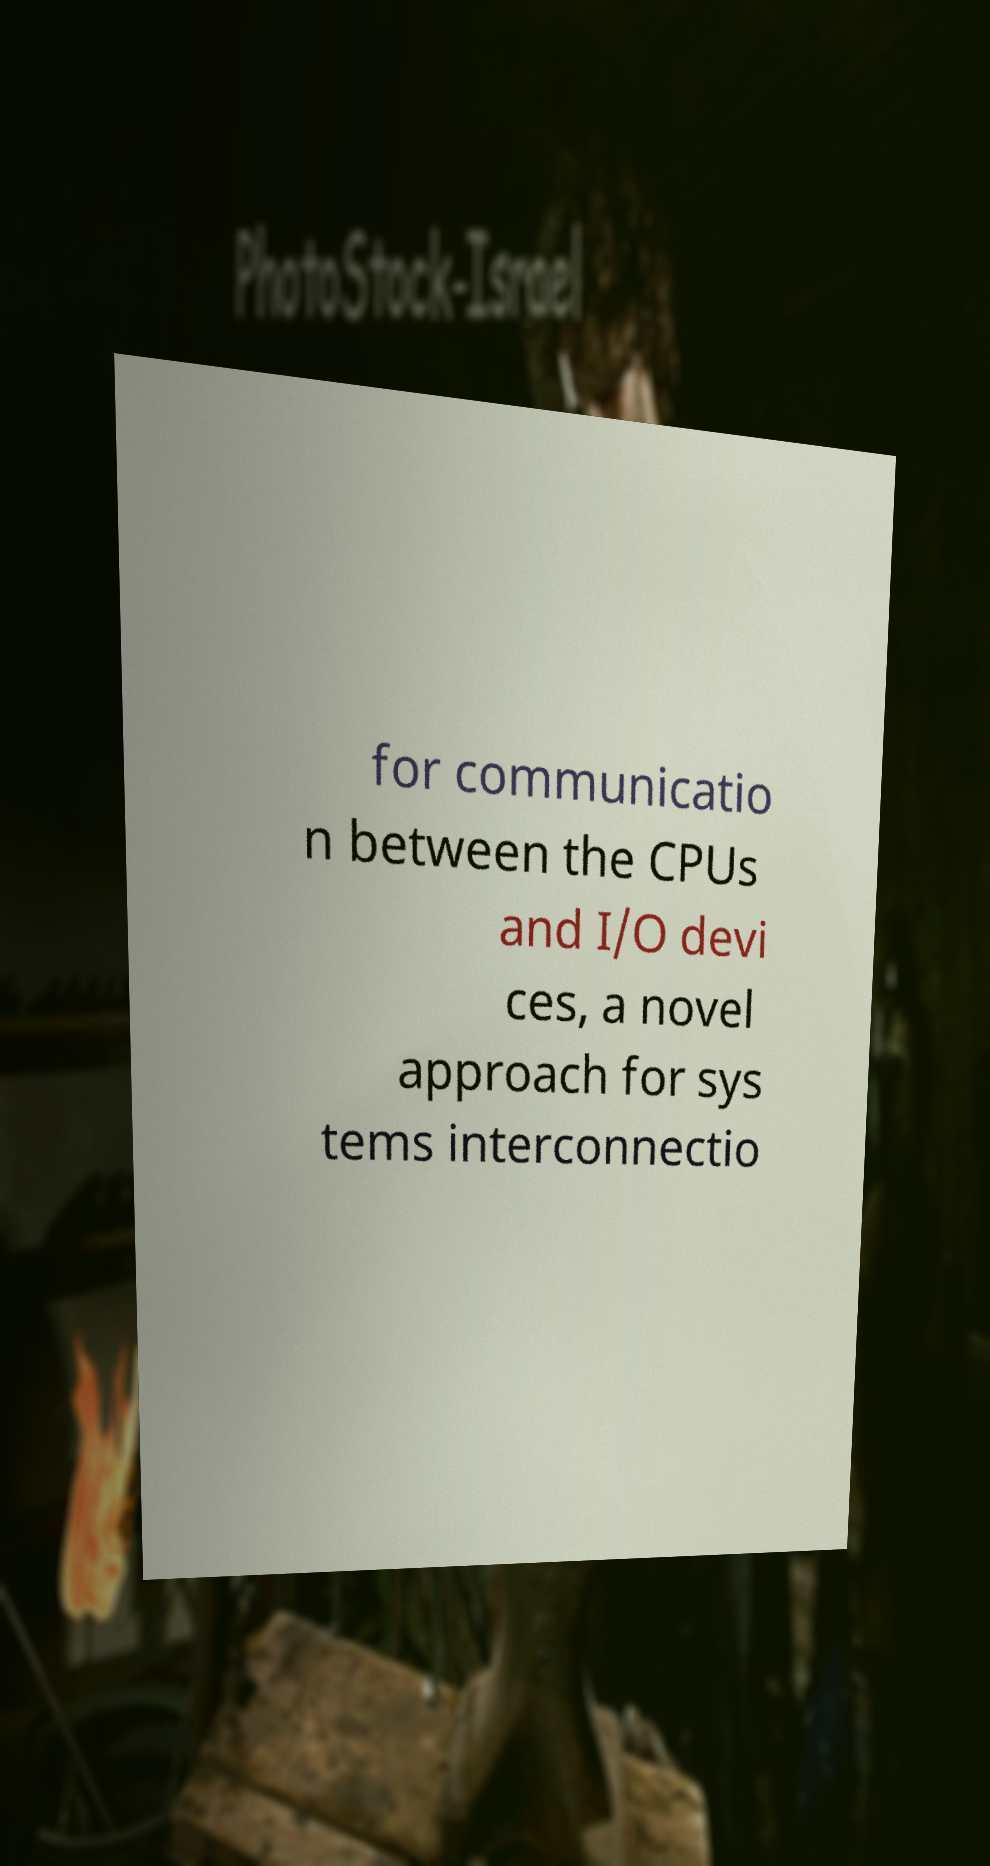Please identify and transcribe the text found in this image. for communicatio n between the CPUs and I/O devi ces, a novel approach for sys tems interconnectio 